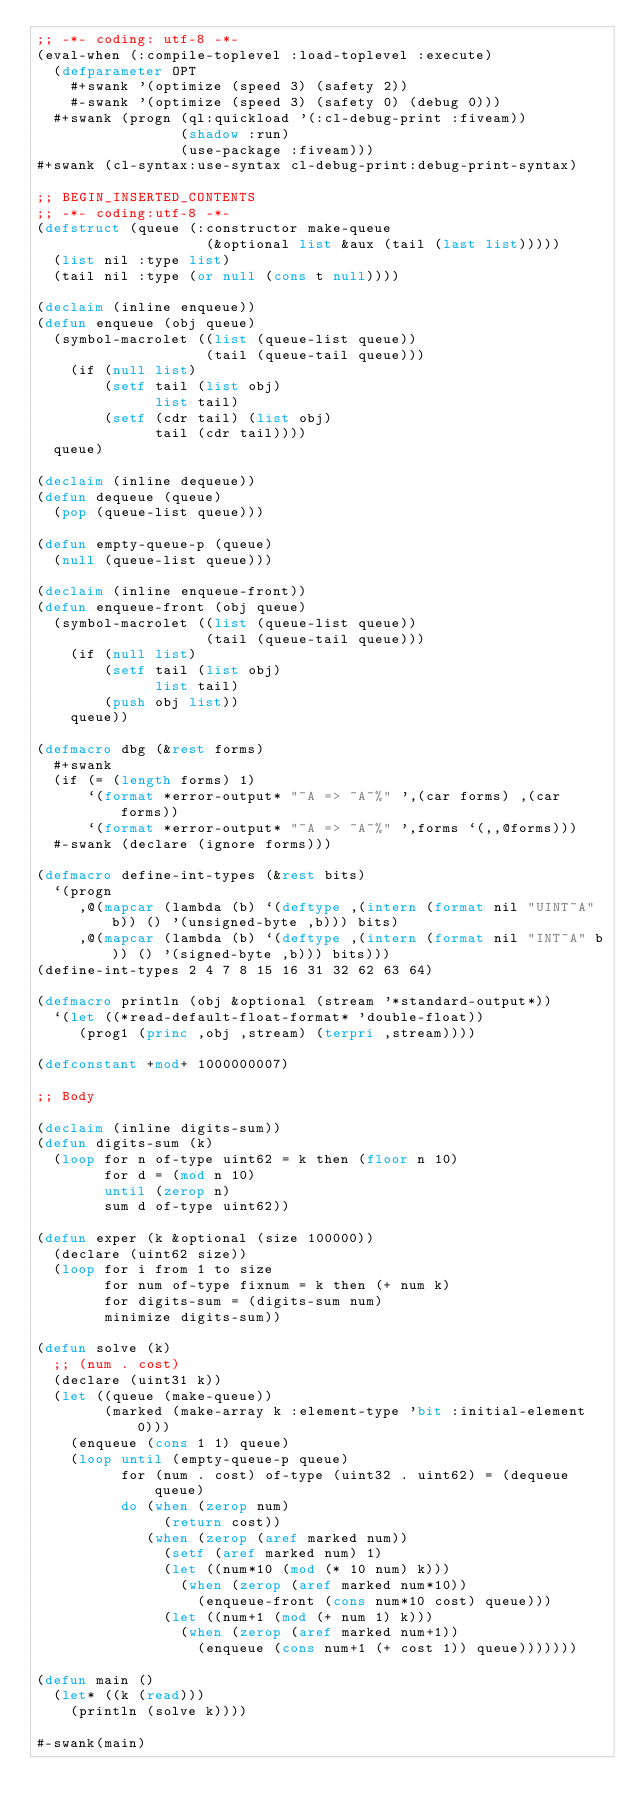Convert code to text. <code><loc_0><loc_0><loc_500><loc_500><_Lisp_>;; -*- coding: utf-8 -*-
(eval-when (:compile-toplevel :load-toplevel :execute)
  (defparameter OPT
    #+swank '(optimize (speed 3) (safety 2))
    #-swank '(optimize (speed 3) (safety 0) (debug 0)))
  #+swank (progn (ql:quickload '(:cl-debug-print :fiveam))
                 (shadow :run)
                 (use-package :fiveam)))
#+swank (cl-syntax:use-syntax cl-debug-print:debug-print-syntax)

;; BEGIN_INSERTED_CONTENTS
;; -*- coding:utf-8 -*-
(defstruct (queue (:constructor make-queue
                    (&optional list &aux (tail (last list)))))
  (list nil :type list)
  (tail nil :type (or null (cons t null))))

(declaim (inline enqueue))
(defun enqueue (obj queue)
  (symbol-macrolet ((list (queue-list queue))
                    (tail (queue-tail queue)))
    (if (null list)
        (setf tail (list obj)
              list tail)
        (setf (cdr tail) (list obj)
              tail (cdr tail))))
  queue)

(declaim (inline dequeue))
(defun dequeue (queue)
  (pop (queue-list queue)))

(defun empty-queue-p (queue)
  (null (queue-list queue)))

(declaim (inline enqueue-front))
(defun enqueue-front (obj queue)
  (symbol-macrolet ((list (queue-list queue))
                    (tail (queue-tail queue)))
    (if (null list)
        (setf tail (list obj)
              list tail)
        (push obj list))
    queue))

(defmacro dbg (&rest forms)
  #+swank
  (if (= (length forms) 1)
      `(format *error-output* "~A => ~A~%" ',(car forms) ,(car forms))
      `(format *error-output* "~A => ~A~%" ',forms `(,,@forms)))
  #-swank (declare (ignore forms)))

(defmacro define-int-types (&rest bits)
  `(progn
     ,@(mapcar (lambda (b) `(deftype ,(intern (format nil "UINT~A" b)) () '(unsigned-byte ,b))) bits)
     ,@(mapcar (lambda (b) `(deftype ,(intern (format nil "INT~A" b)) () '(signed-byte ,b))) bits)))
(define-int-types 2 4 7 8 15 16 31 32 62 63 64)

(defmacro println (obj &optional (stream '*standard-output*))
  `(let ((*read-default-float-format* 'double-float))
     (prog1 (princ ,obj ,stream) (terpri ,stream))))

(defconstant +mod+ 1000000007)

;; Body

(declaim (inline digits-sum))
(defun digits-sum (k)
  (loop for n of-type uint62 = k then (floor n 10)
        for d = (mod n 10)
        until (zerop n)
        sum d of-type uint62))

(defun exper (k &optional (size 100000))
  (declare (uint62 size))
  (loop for i from 1 to size
        for num of-type fixnum = k then (+ num k)
        for digits-sum = (digits-sum num)
        minimize digits-sum))

(defun solve (k)
  ;; (num . cost)
  (declare (uint31 k))
  (let ((queue (make-queue))
        (marked (make-array k :element-type 'bit :initial-element 0)))
    (enqueue (cons 1 1) queue)
    (loop until (empty-queue-p queue)
          for (num . cost) of-type (uint32 . uint62) = (dequeue queue)
          do (when (zerop num)
               (return cost))
             (when (zerop (aref marked num))
               (setf (aref marked num) 1)
               (let ((num*10 (mod (* 10 num) k)))
                 (when (zerop (aref marked num*10))
                   (enqueue-front (cons num*10 cost) queue)))
               (let ((num+1 (mod (+ num 1) k)))
                 (when (zerop (aref marked num+1))
                   (enqueue (cons num+1 (+ cost 1)) queue)))))))

(defun main ()
  (let* ((k (read)))
    (println (solve k))))

#-swank(main)
</code> 